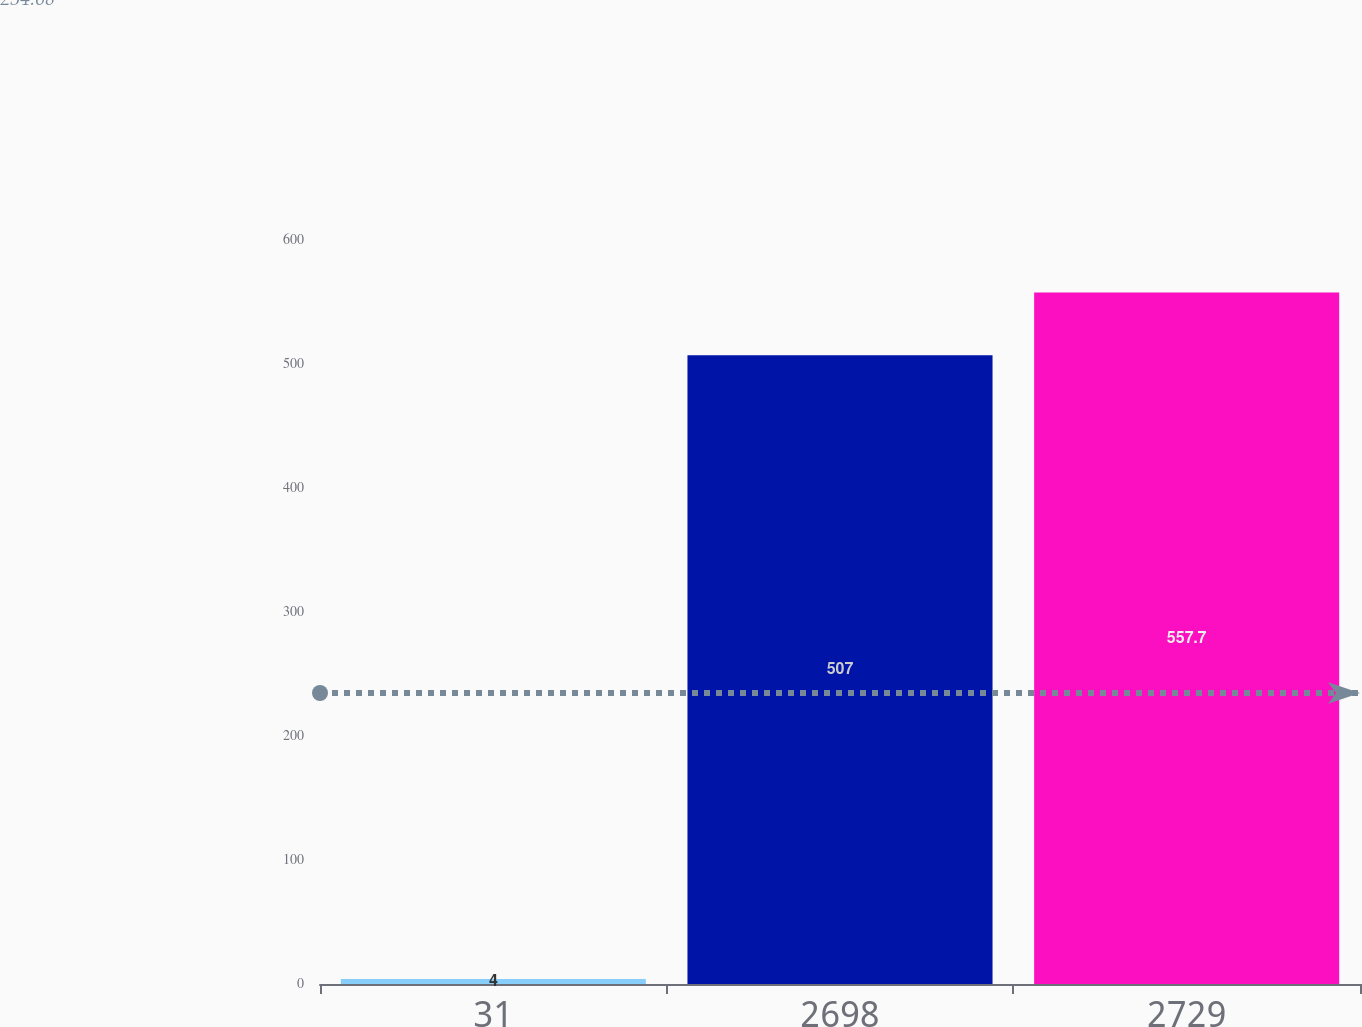Convert chart. <chart><loc_0><loc_0><loc_500><loc_500><bar_chart><fcel>31<fcel>2698<fcel>2729<nl><fcel>4<fcel>507<fcel>557.7<nl></chart> 